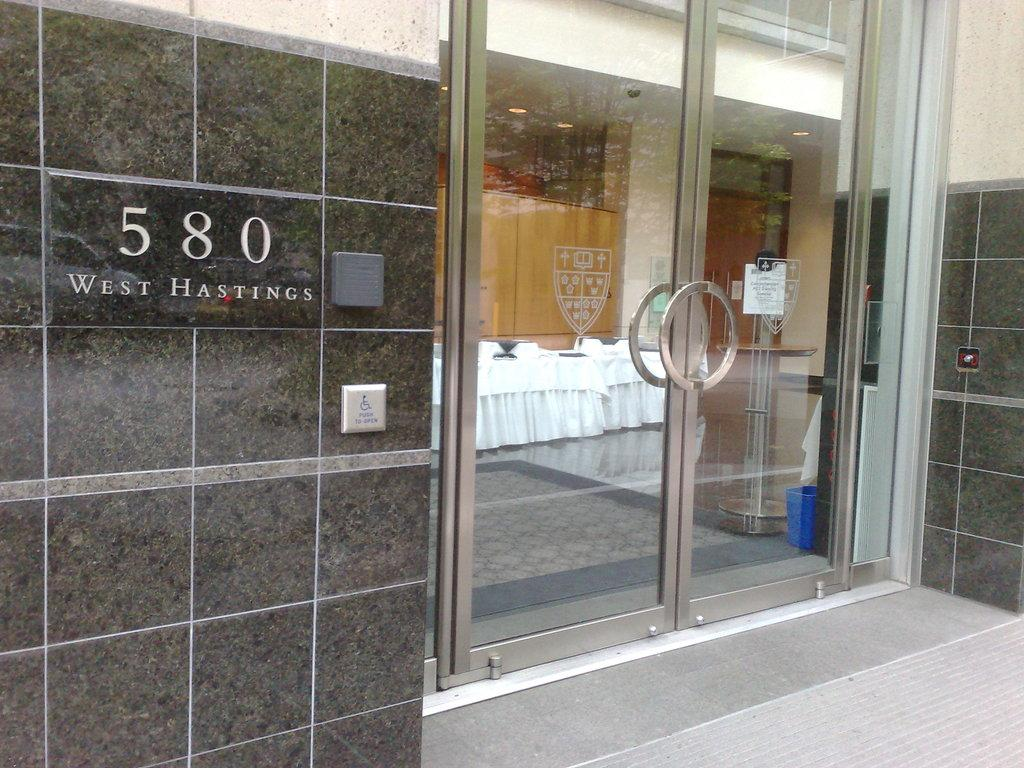What type of structure is visible in the image? There is a building in the image. What can be seen on the wall of the building? There is text on the wall of the building. What type of entrance is present in the building? There is a glass door in the building. What can be seen inside the building through the glass door? Tables and chairs are arranged inside the building, visible through the glass door. What type of fuel is being used to power the beds in the image? There are no beds present in the image, so the question about fuel is not applicable. 